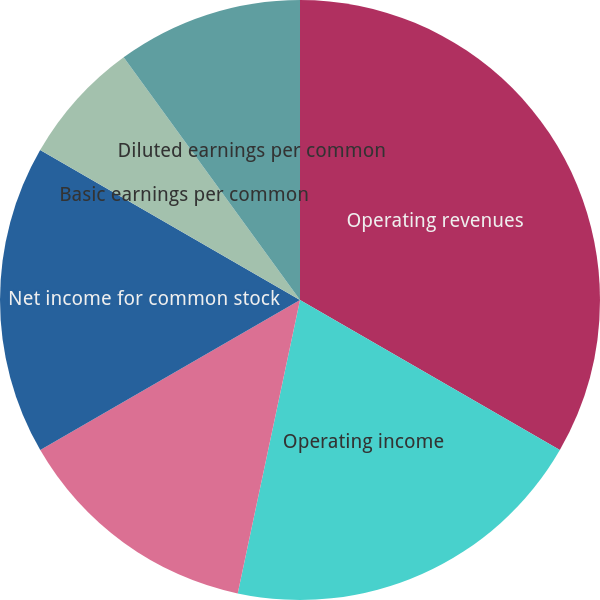<chart> <loc_0><loc_0><loc_500><loc_500><pie_chart><fcel>Operating revenues<fcel>Operating income<fcel>Income for common stock before<fcel>Net income for common stock<fcel>Basic earnings per common<fcel>Diluted earnings per common<nl><fcel>33.33%<fcel>20.0%<fcel>13.33%<fcel>16.67%<fcel>6.67%<fcel>10.0%<nl></chart> 